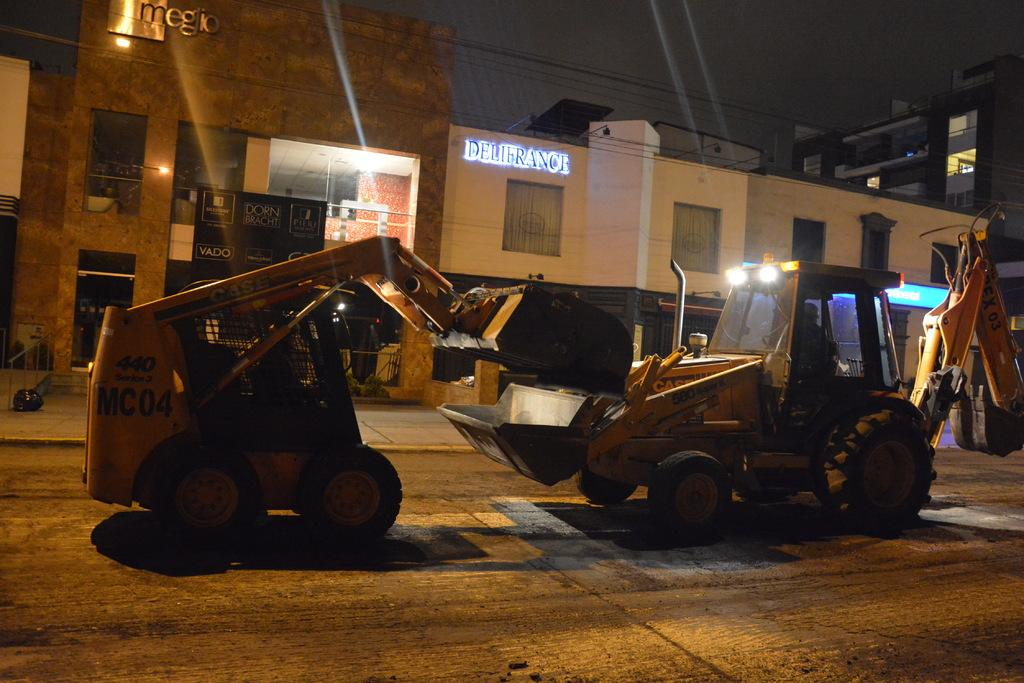<image>
Summarize the visual content of the image. Two construction diggers face off in front of a Delifrance establishment. 